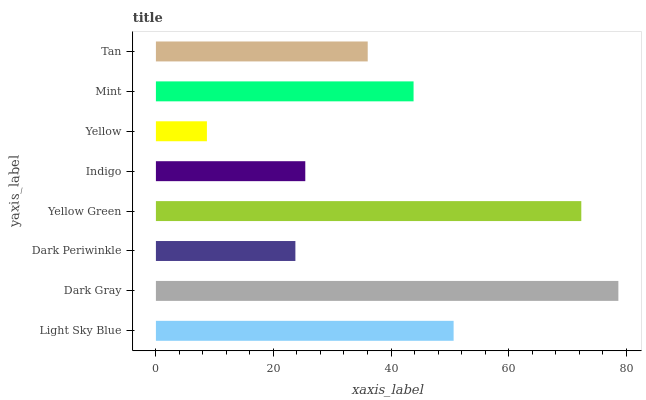Is Yellow the minimum?
Answer yes or no. Yes. Is Dark Gray the maximum?
Answer yes or no. Yes. Is Dark Periwinkle the minimum?
Answer yes or no. No. Is Dark Periwinkle the maximum?
Answer yes or no. No. Is Dark Gray greater than Dark Periwinkle?
Answer yes or no. Yes. Is Dark Periwinkle less than Dark Gray?
Answer yes or no. Yes. Is Dark Periwinkle greater than Dark Gray?
Answer yes or no. No. Is Dark Gray less than Dark Periwinkle?
Answer yes or no. No. Is Mint the high median?
Answer yes or no. Yes. Is Tan the low median?
Answer yes or no. Yes. Is Dark Gray the high median?
Answer yes or no. No. Is Dark Gray the low median?
Answer yes or no. No. 